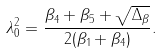Convert formula to latex. <formula><loc_0><loc_0><loc_500><loc_500>\lambda _ { 0 } ^ { 2 } = \frac { \beta _ { 4 } + \beta _ { 5 } + \sqrt { \Delta _ { \beta } } } { 2 ( \beta _ { 1 } + \beta _ { 4 } ) } .</formula> 